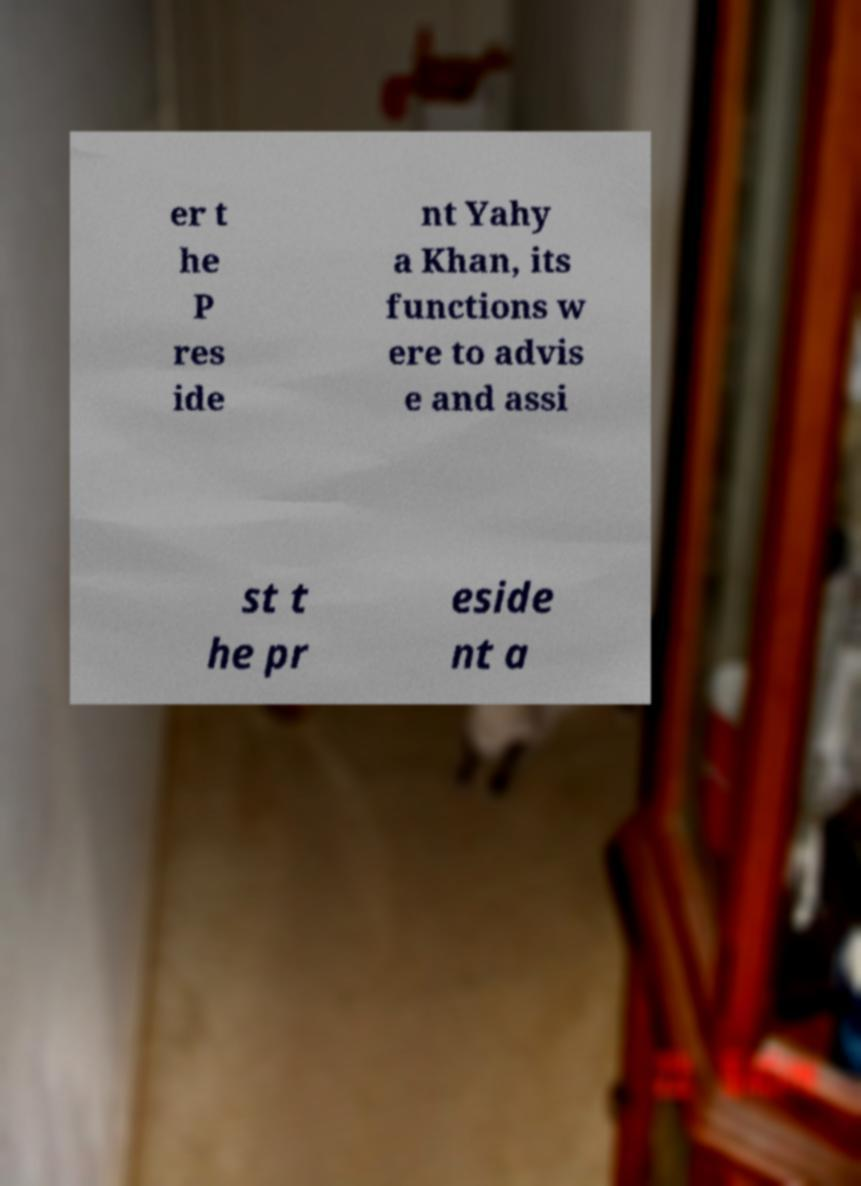What messages or text are displayed in this image? I need them in a readable, typed format. er t he P res ide nt Yahy a Khan, its functions w ere to advis e and assi st t he pr eside nt a 